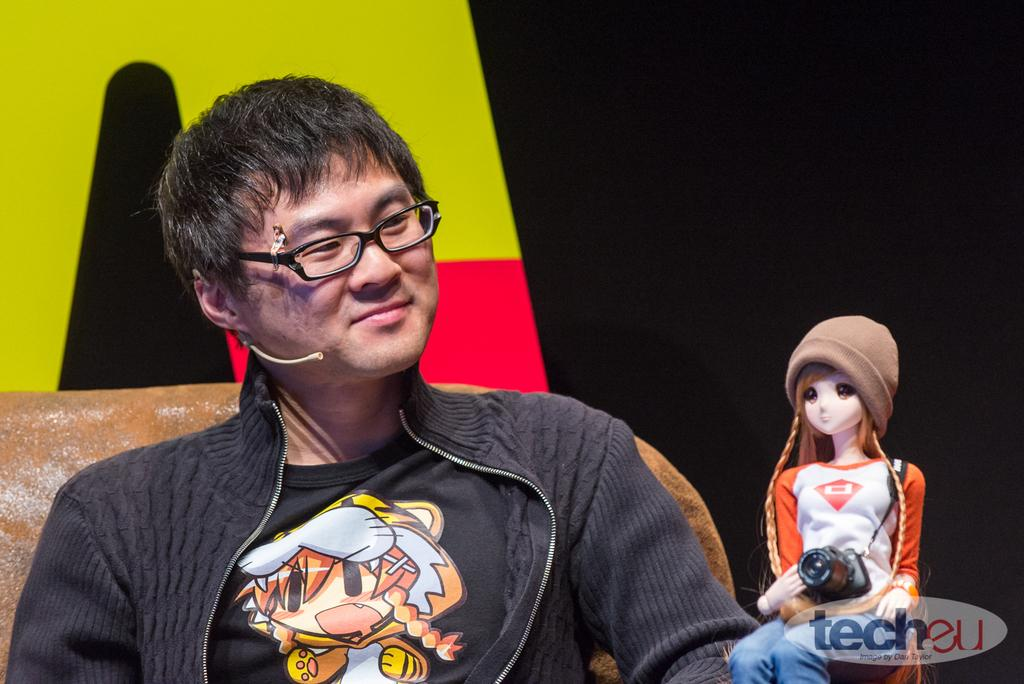What is the person in the image doing? There is a person sitting in the image. What is the person wearing? The person is wearing a black dress. What other object can be seen in the image? There is a toy person in the image. What colors are present in the background of the image? The background of the image has black, red, and green colors. What type of food is the person eating in the image? There is no food present in the image, so it cannot be determined what the person might be eating. 